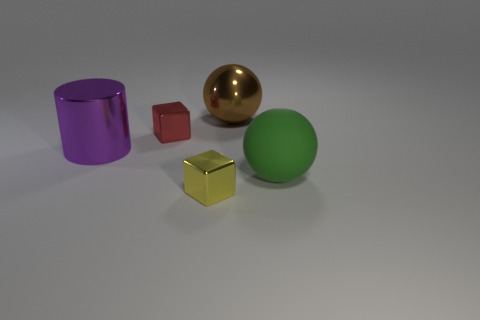Are there any other things that have the same material as the green sphere?
Offer a terse response. No. There is a tiny block that is the same material as the yellow thing; what is its color?
Provide a succinct answer. Red. There is a small red metallic block; how many metallic blocks are in front of it?
Provide a short and direct response. 1. There is another tiny object that is the same shape as the tiny red shiny thing; what is its color?
Your answer should be compact. Yellow. Is there anything else that is the same shape as the big purple object?
Provide a short and direct response. No. Do the large shiny object that is on the left side of the big brown thing and the tiny object that is in front of the big green rubber sphere have the same shape?
Offer a terse response. No. There is a purple cylinder; does it have the same size as the shiny block in front of the red shiny thing?
Your answer should be very brief. No. Are there more small blue matte things than cylinders?
Make the answer very short. No. Does the purple thing that is in front of the red metal cube have the same material as the tiny object on the left side of the tiny yellow shiny thing?
Your answer should be compact. Yes. What material is the large green thing?
Your answer should be compact. Rubber. 